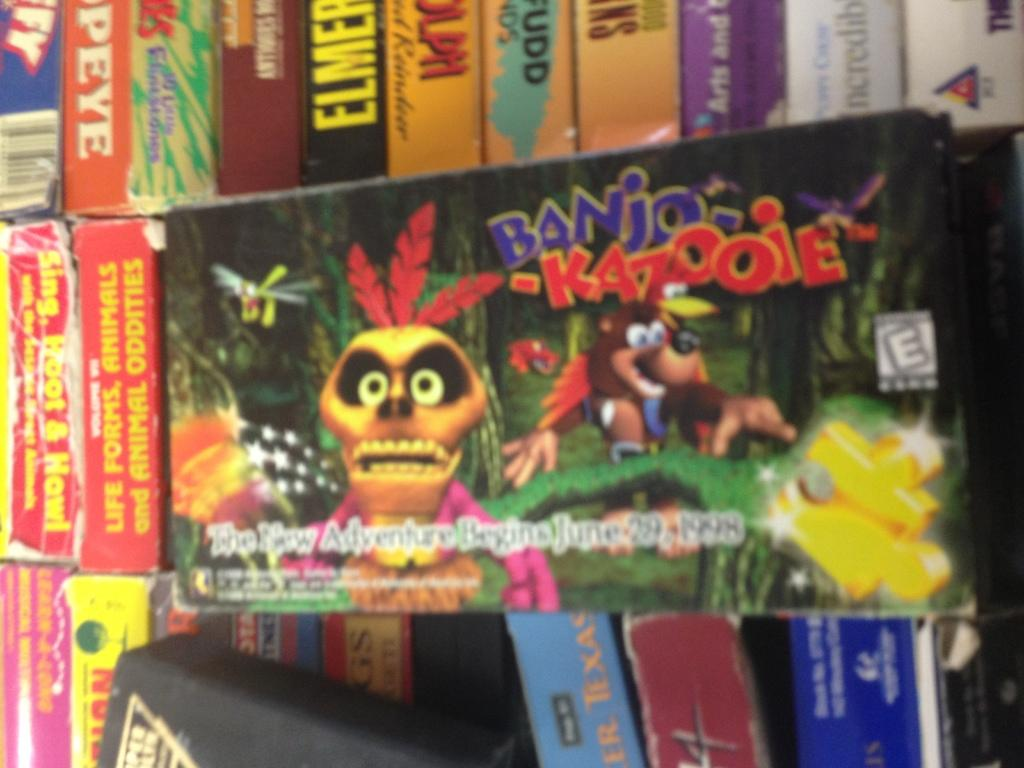<image>
Describe the image concisely. A sign in front of boxes of videos advertises a game called Banjo-kazooie. 